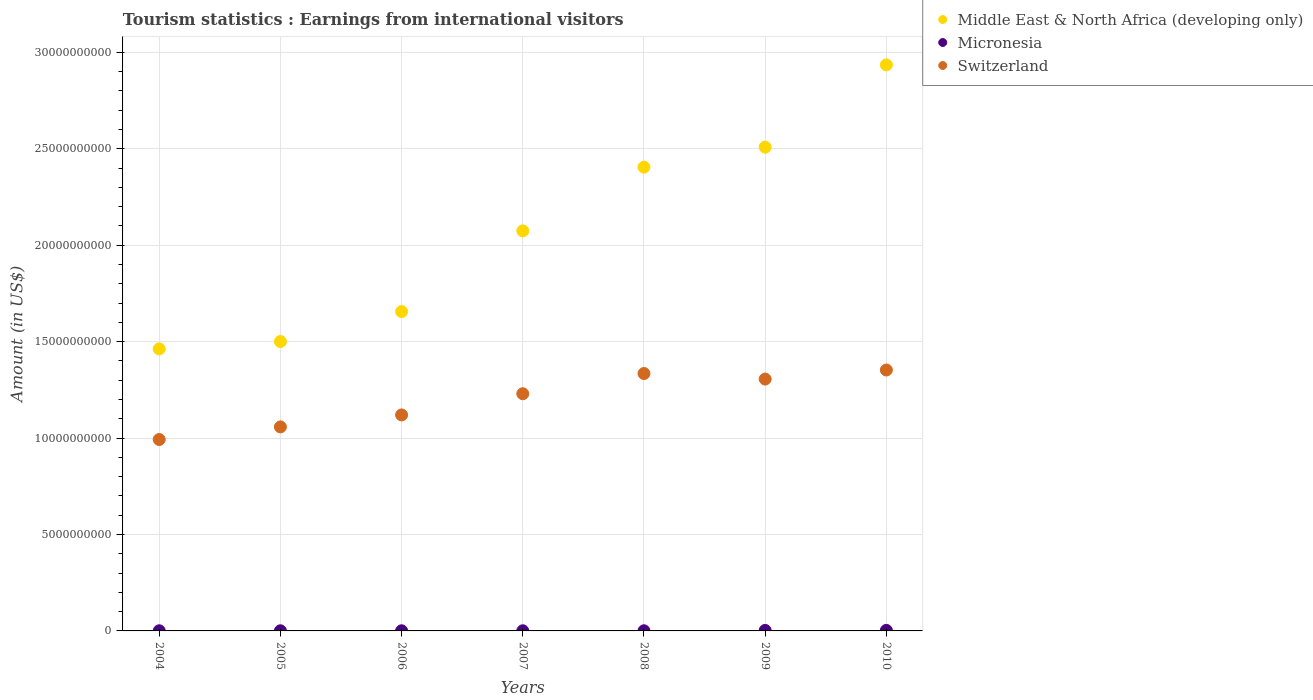How many different coloured dotlines are there?
Offer a terse response. 3. What is the earnings from international visitors in Middle East & North Africa (developing only) in 2009?
Your answer should be compact. 2.51e+1. Across all years, what is the maximum earnings from international visitors in Middle East & North Africa (developing only)?
Provide a short and direct response. 2.93e+1. Across all years, what is the minimum earnings from international visitors in Middle East & North Africa (developing only)?
Your answer should be very brief. 1.46e+1. In which year was the earnings from international visitors in Micronesia maximum?
Your response must be concise. 2010. What is the total earnings from international visitors in Middle East & North Africa (developing only) in the graph?
Offer a terse response. 1.45e+11. What is the difference between the earnings from international visitors in Micronesia in 2006 and that in 2008?
Your answer should be very brief. 0. What is the difference between the earnings from international visitors in Middle East & North Africa (developing only) in 2004 and the earnings from international visitors in Switzerland in 2010?
Your response must be concise. 1.10e+09. What is the average earnings from international visitors in Middle East & North Africa (developing only) per year?
Make the answer very short. 2.08e+1. In the year 2007, what is the difference between the earnings from international visitors in Middle East & North Africa (developing only) and earnings from international visitors in Micronesia?
Offer a terse response. 2.07e+1. What is the ratio of the earnings from international visitors in Micronesia in 2004 to that in 2005?
Provide a short and direct response. 1. Is the difference between the earnings from international visitors in Middle East & North Africa (developing only) in 2006 and 2008 greater than the difference between the earnings from international visitors in Micronesia in 2006 and 2008?
Make the answer very short. No. What is the difference between the highest and the second highest earnings from international visitors in Micronesia?
Give a very brief answer. 2.00e+06. What is the difference between the highest and the lowest earnings from international visitors in Micronesia?
Offer a terse response. 2.10e+07. In how many years, is the earnings from international visitors in Micronesia greater than the average earnings from international visitors in Micronesia taken over all years?
Provide a succinct answer. 2. Is the sum of the earnings from international visitors in Switzerland in 2005 and 2009 greater than the maximum earnings from international visitors in Micronesia across all years?
Offer a terse response. Yes. Is it the case that in every year, the sum of the earnings from international visitors in Micronesia and earnings from international visitors in Middle East & North Africa (developing only)  is greater than the earnings from international visitors in Switzerland?
Your response must be concise. Yes. How many dotlines are there?
Give a very brief answer. 3. Are the values on the major ticks of Y-axis written in scientific E-notation?
Keep it short and to the point. No. How are the legend labels stacked?
Make the answer very short. Vertical. What is the title of the graph?
Give a very brief answer. Tourism statistics : Earnings from international visitors. What is the label or title of the X-axis?
Provide a succinct answer. Years. What is the label or title of the Y-axis?
Keep it short and to the point. Amount (in US$). What is the Amount (in US$) in Middle East & North Africa (developing only) in 2004?
Your answer should be compact. 1.46e+1. What is the Amount (in US$) of Micronesia in 2004?
Give a very brief answer. 7.00e+06. What is the Amount (in US$) in Switzerland in 2004?
Offer a terse response. 9.92e+09. What is the Amount (in US$) in Middle East & North Africa (developing only) in 2005?
Make the answer very short. 1.50e+1. What is the Amount (in US$) of Micronesia in 2005?
Offer a terse response. 7.00e+06. What is the Amount (in US$) in Switzerland in 2005?
Make the answer very short. 1.06e+1. What is the Amount (in US$) in Middle East & North Africa (developing only) in 2006?
Your answer should be compact. 1.66e+1. What is the Amount (in US$) in Micronesia in 2006?
Provide a short and direct response. 7.00e+06. What is the Amount (in US$) in Switzerland in 2006?
Your answer should be very brief. 1.12e+1. What is the Amount (in US$) in Middle East & North Africa (developing only) in 2007?
Ensure brevity in your answer.  2.07e+1. What is the Amount (in US$) in Micronesia in 2007?
Your answer should be very brief. 7.00e+06. What is the Amount (in US$) in Switzerland in 2007?
Ensure brevity in your answer.  1.23e+1. What is the Amount (in US$) in Middle East & North Africa (developing only) in 2008?
Provide a succinct answer. 2.40e+1. What is the Amount (in US$) in Switzerland in 2008?
Give a very brief answer. 1.33e+1. What is the Amount (in US$) of Middle East & North Africa (developing only) in 2009?
Ensure brevity in your answer.  2.51e+1. What is the Amount (in US$) of Micronesia in 2009?
Provide a short and direct response. 2.60e+07. What is the Amount (in US$) in Switzerland in 2009?
Make the answer very short. 1.31e+1. What is the Amount (in US$) of Middle East & North Africa (developing only) in 2010?
Ensure brevity in your answer.  2.93e+1. What is the Amount (in US$) in Micronesia in 2010?
Your answer should be compact. 2.80e+07. What is the Amount (in US$) of Switzerland in 2010?
Your answer should be very brief. 1.35e+1. Across all years, what is the maximum Amount (in US$) in Middle East & North Africa (developing only)?
Your answer should be very brief. 2.93e+1. Across all years, what is the maximum Amount (in US$) in Micronesia?
Give a very brief answer. 2.80e+07. Across all years, what is the maximum Amount (in US$) in Switzerland?
Give a very brief answer. 1.35e+1. Across all years, what is the minimum Amount (in US$) in Middle East & North Africa (developing only)?
Keep it short and to the point. 1.46e+1. Across all years, what is the minimum Amount (in US$) of Micronesia?
Your answer should be compact. 7.00e+06. Across all years, what is the minimum Amount (in US$) in Switzerland?
Your response must be concise. 9.92e+09. What is the total Amount (in US$) in Middle East & North Africa (developing only) in the graph?
Provide a short and direct response. 1.45e+11. What is the total Amount (in US$) of Micronesia in the graph?
Provide a succinct answer. 8.90e+07. What is the total Amount (in US$) in Switzerland in the graph?
Ensure brevity in your answer.  8.39e+1. What is the difference between the Amount (in US$) of Middle East & North Africa (developing only) in 2004 and that in 2005?
Your response must be concise. -3.82e+08. What is the difference between the Amount (in US$) of Switzerland in 2004 and that in 2005?
Offer a very short reply. -6.55e+08. What is the difference between the Amount (in US$) in Middle East & North Africa (developing only) in 2004 and that in 2006?
Offer a very short reply. -1.93e+09. What is the difference between the Amount (in US$) in Micronesia in 2004 and that in 2006?
Keep it short and to the point. 0. What is the difference between the Amount (in US$) in Switzerland in 2004 and that in 2006?
Your answer should be very brief. -1.28e+09. What is the difference between the Amount (in US$) of Middle East & North Africa (developing only) in 2004 and that in 2007?
Your answer should be very brief. -6.12e+09. What is the difference between the Amount (in US$) in Micronesia in 2004 and that in 2007?
Your answer should be compact. 0. What is the difference between the Amount (in US$) of Switzerland in 2004 and that in 2007?
Your answer should be compact. -2.37e+09. What is the difference between the Amount (in US$) in Middle East & North Africa (developing only) in 2004 and that in 2008?
Offer a very short reply. -9.42e+09. What is the difference between the Amount (in US$) in Micronesia in 2004 and that in 2008?
Your answer should be very brief. 0. What is the difference between the Amount (in US$) of Switzerland in 2004 and that in 2008?
Keep it short and to the point. -3.42e+09. What is the difference between the Amount (in US$) in Middle East & North Africa (developing only) in 2004 and that in 2009?
Ensure brevity in your answer.  -1.05e+1. What is the difference between the Amount (in US$) in Micronesia in 2004 and that in 2009?
Keep it short and to the point. -1.90e+07. What is the difference between the Amount (in US$) in Switzerland in 2004 and that in 2009?
Offer a terse response. -3.13e+09. What is the difference between the Amount (in US$) in Middle East & North Africa (developing only) in 2004 and that in 2010?
Make the answer very short. -1.47e+1. What is the difference between the Amount (in US$) of Micronesia in 2004 and that in 2010?
Offer a terse response. -2.10e+07. What is the difference between the Amount (in US$) of Switzerland in 2004 and that in 2010?
Make the answer very short. -3.60e+09. What is the difference between the Amount (in US$) of Middle East & North Africa (developing only) in 2005 and that in 2006?
Ensure brevity in your answer.  -1.55e+09. What is the difference between the Amount (in US$) of Switzerland in 2005 and that in 2006?
Provide a short and direct response. -6.20e+08. What is the difference between the Amount (in US$) of Middle East & North Africa (developing only) in 2005 and that in 2007?
Keep it short and to the point. -5.74e+09. What is the difference between the Amount (in US$) of Micronesia in 2005 and that in 2007?
Give a very brief answer. 0. What is the difference between the Amount (in US$) in Switzerland in 2005 and that in 2007?
Your answer should be compact. -1.72e+09. What is the difference between the Amount (in US$) of Middle East & North Africa (developing only) in 2005 and that in 2008?
Your answer should be very brief. -9.04e+09. What is the difference between the Amount (in US$) of Switzerland in 2005 and that in 2008?
Give a very brief answer. -2.77e+09. What is the difference between the Amount (in US$) of Middle East & North Africa (developing only) in 2005 and that in 2009?
Make the answer very short. -1.01e+1. What is the difference between the Amount (in US$) in Micronesia in 2005 and that in 2009?
Your answer should be very brief. -1.90e+07. What is the difference between the Amount (in US$) of Switzerland in 2005 and that in 2009?
Your answer should be compact. -2.48e+09. What is the difference between the Amount (in US$) in Middle East & North Africa (developing only) in 2005 and that in 2010?
Provide a short and direct response. -1.43e+1. What is the difference between the Amount (in US$) of Micronesia in 2005 and that in 2010?
Make the answer very short. -2.10e+07. What is the difference between the Amount (in US$) of Switzerland in 2005 and that in 2010?
Provide a succinct answer. -2.95e+09. What is the difference between the Amount (in US$) of Middle East & North Africa (developing only) in 2006 and that in 2007?
Ensure brevity in your answer.  -4.18e+09. What is the difference between the Amount (in US$) in Switzerland in 2006 and that in 2007?
Make the answer very short. -1.10e+09. What is the difference between the Amount (in US$) of Middle East & North Africa (developing only) in 2006 and that in 2008?
Make the answer very short. -7.49e+09. What is the difference between the Amount (in US$) of Micronesia in 2006 and that in 2008?
Your response must be concise. 0. What is the difference between the Amount (in US$) of Switzerland in 2006 and that in 2008?
Your answer should be compact. -2.15e+09. What is the difference between the Amount (in US$) of Middle East & North Africa (developing only) in 2006 and that in 2009?
Your answer should be compact. -8.52e+09. What is the difference between the Amount (in US$) of Micronesia in 2006 and that in 2009?
Offer a very short reply. -1.90e+07. What is the difference between the Amount (in US$) in Switzerland in 2006 and that in 2009?
Make the answer very short. -1.86e+09. What is the difference between the Amount (in US$) in Middle East & North Africa (developing only) in 2006 and that in 2010?
Keep it short and to the point. -1.28e+1. What is the difference between the Amount (in US$) in Micronesia in 2006 and that in 2010?
Your response must be concise. -2.10e+07. What is the difference between the Amount (in US$) in Switzerland in 2006 and that in 2010?
Your answer should be compact. -2.33e+09. What is the difference between the Amount (in US$) in Middle East & North Africa (developing only) in 2007 and that in 2008?
Offer a terse response. -3.30e+09. What is the difference between the Amount (in US$) of Micronesia in 2007 and that in 2008?
Keep it short and to the point. 0. What is the difference between the Amount (in US$) of Switzerland in 2007 and that in 2008?
Make the answer very short. -1.05e+09. What is the difference between the Amount (in US$) of Middle East & North Africa (developing only) in 2007 and that in 2009?
Provide a short and direct response. -4.34e+09. What is the difference between the Amount (in US$) in Micronesia in 2007 and that in 2009?
Your answer should be very brief. -1.90e+07. What is the difference between the Amount (in US$) in Switzerland in 2007 and that in 2009?
Your answer should be compact. -7.60e+08. What is the difference between the Amount (in US$) in Middle East & North Africa (developing only) in 2007 and that in 2010?
Give a very brief answer. -8.61e+09. What is the difference between the Amount (in US$) in Micronesia in 2007 and that in 2010?
Provide a succinct answer. -2.10e+07. What is the difference between the Amount (in US$) of Switzerland in 2007 and that in 2010?
Provide a succinct answer. -1.23e+09. What is the difference between the Amount (in US$) in Middle East & North Africa (developing only) in 2008 and that in 2009?
Your answer should be compact. -1.04e+09. What is the difference between the Amount (in US$) of Micronesia in 2008 and that in 2009?
Provide a succinct answer. -1.90e+07. What is the difference between the Amount (in US$) of Switzerland in 2008 and that in 2009?
Your answer should be very brief. 2.88e+08. What is the difference between the Amount (in US$) in Middle East & North Africa (developing only) in 2008 and that in 2010?
Your response must be concise. -5.30e+09. What is the difference between the Amount (in US$) in Micronesia in 2008 and that in 2010?
Make the answer very short. -2.10e+07. What is the difference between the Amount (in US$) of Switzerland in 2008 and that in 2010?
Make the answer very short. -1.82e+08. What is the difference between the Amount (in US$) of Middle East & North Africa (developing only) in 2009 and that in 2010?
Make the answer very short. -4.27e+09. What is the difference between the Amount (in US$) in Switzerland in 2009 and that in 2010?
Your response must be concise. -4.70e+08. What is the difference between the Amount (in US$) of Middle East & North Africa (developing only) in 2004 and the Amount (in US$) of Micronesia in 2005?
Give a very brief answer. 1.46e+1. What is the difference between the Amount (in US$) in Middle East & North Africa (developing only) in 2004 and the Amount (in US$) in Switzerland in 2005?
Your answer should be very brief. 4.04e+09. What is the difference between the Amount (in US$) in Micronesia in 2004 and the Amount (in US$) in Switzerland in 2005?
Ensure brevity in your answer.  -1.06e+1. What is the difference between the Amount (in US$) of Middle East & North Africa (developing only) in 2004 and the Amount (in US$) of Micronesia in 2006?
Keep it short and to the point. 1.46e+1. What is the difference between the Amount (in US$) in Middle East & North Africa (developing only) in 2004 and the Amount (in US$) in Switzerland in 2006?
Ensure brevity in your answer.  3.42e+09. What is the difference between the Amount (in US$) in Micronesia in 2004 and the Amount (in US$) in Switzerland in 2006?
Your response must be concise. -1.12e+1. What is the difference between the Amount (in US$) in Middle East & North Africa (developing only) in 2004 and the Amount (in US$) in Micronesia in 2007?
Keep it short and to the point. 1.46e+1. What is the difference between the Amount (in US$) of Middle East & North Africa (developing only) in 2004 and the Amount (in US$) of Switzerland in 2007?
Make the answer very short. 2.33e+09. What is the difference between the Amount (in US$) of Micronesia in 2004 and the Amount (in US$) of Switzerland in 2007?
Provide a short and direct response. -1.23e+1. What is the difference between the Amount (in US$) in Middle East & North Africa (developing only) in 2004 and the Amount (in US$) in Micronesia in 2008?
Provide a short and direct response. 1.46e+1. What is the difference between the Amount (in US$) of Middle East & North Africa (developing only) in 2004 and the Amount (in US$) of Switzerland in 2008?
Provide a succinct answer. 1.28e+09. What is the difference between the Amount (in US$) of Micronesia in 2004 and the Amount (in US$) of Switzerland in 2008?
Make the answer very short. -1.33e+1. What is the difference between the Amount (in US$) in Middle East & North Africa (developing only) in 2004 and the Amount (in US$) in Micronesia in 2009?
Offer a very short reply. 1.46e+1. What is the difference between the Amount (in US$) in Middle East & North Africa (developing only) in 2004 and the Amount (in US$) in Switzerland in 2009?
Your response must be concise. 1.57e+09. What is the difference between the Amount (in US$) in Micronesia in 2004 and the Amount (in US$) in Switzerland in 2009?
Your answer should be very brief. -1.31e+1. What is the difference between the Amount (in US$) of Middle East & North Africa (developing only) in 2004 and the Amount (in US$) of Micronesia in 2010?
Provide a succinct answer. 1.46e+1. What is the difference between the Amount (in US$) of Middle East & North Africa (developing only) in 2004 and the Amount (in US$) of Switzerland in 2010?
Give a very brief answer. 1.10e+09. What is the difference between the Amount (in US$) in Micronesia in 2004 and the Amount (in US$) in Switzerland in 2010?
Offer a terse response. -1.35e+1. What is the difference between the Amount (in US$) of Middle East & North Africa (developing only) in 2005 and the Amount (in US$) of Micronesia in 2006?
Make the answer very short. 1.50e+1. What is the difference between the Amount (in US$) of Middle East & North Africa (developing only) in 2005 and the Amount (in US$) of Switzerland in 2006?
Provide a succinct answer. 3.81e+09. What is the difference between the Amount (in US$) of Micronesia in 2005 and the Amount (in US$) of Switzerland in 2006?
Offer a very short reply. -1.12e+1. What is the difference between the Amount (in US$) of Middle East & North Africa (developing only) in 2005 and the Amount (in US$) of Micronesia in 2007?
Provide a short and direct response. 1.50e+1. What is the difference between the Amount (in US$) in Middle East & North Africa (developing only) in 2005 and the Amount (in US$) in Switzerland in 2007?
Offer a terse response. 2.71e+09. What is the difference between the Amount (in US$) of Micronesia in 2005 and the Amount (in US$) of Switzerland in 2007?
Provide a succinct answer. -1.23e+1. What is the difference between the Amount (in US$) of Middle East & North Africa (developing only) in 2005 and the Amount (in US$) of Micronesia in 2008?
Offer a terse response. 1.50e+1. What is the difference between the Amount (in US$) of Middle East & North Africa (developing only) in 2005 and the Amount (in US$) of Switzerland in 2008?
Provide a short and direct response. 1.66e+09. What is the difference between the Amount (in US$) of Micronesia in 2005 and the Amount (in US$) of Switzerland in 2008?
Your answer should be compact. -1.33e+1. What is the difference between the Amount (in US$) in Middle East & North Africa (developing only) in 2005 and the Amount (in US$) in Micronesia in 2009?
Your response must be concise. 1.50e+1. What is the difference between the Amount (in US$) in Middle East & North Africa (developing only) in 2005 and the Amount (in US$) in Switzerland in 2009?
Make the answer very short. 1.95e+09. What is the difference between the Amount (in US$) in Micronesia in 2005 and the Amount (in US$) in Switzerland in 2009?
Give a very brief answer. -1.31e+1. What is the difference between the Amount (in US$) in Middle East & North Africa (developing only) in 2005 and the Amount (in US$) in Micronesia in 2010?
Provide a succinct answer. 1.50e+1. What is the difference between the Amount (in US$) of Middle East & North Africa (developing only) in 2005 and the Amount (in US$) of Switzerland in 2010?
Offer a terse response. 1.48e+09. What is the difference between the Amount (in US$) in Micronesia in 2005 and the Amount (in US$) in Switzerland in 2010?
Offer a terse response. -1.35e+1. What is the difference between the Amount (in US$) of Middle East & North Africa (developing only) in 2006 and the Amount (in US$) of Micronesia in 2007?
Give a very brief answer. 1.66e+1. What is the difference between the Amount (in US$) of Middle East & North Africa (developing only) in 2006 and the Amount (in US$) of Switzerland in 2007?
Make the answer very short. 4.26e+09. What is the difference between the Amount (in US$) in Micronesia in 2006 and the Amount (in US$) in Switzerland in 2007?
Your response must be concise. -1.23e+1. What is the difference between the Amount (in US$) in Middle East & North Africa (developing only) in 2006 and the Amount (in US$) in Micronesia in 2008?
Provide a short and direct response. 1.66e+1. What is the difference between the Amount (in US$) in Middle East & North Africa (developing only) in 2006 and the Amount (in US$) in Switzerland in 2008?
Your answer should be very brief. 3.21e+09. What is the difference between the Amount (in US$) of Micronesia in 2006 and the Amount (in US$) of Switzerland in 2008?
Make the answer very short. -1.33e+1. What is the difference between the Amount (in US$) in Middle East & North Africa (developing only) in 2006 and the Amount (in US$) in Micronesia in 2009?
Keep it short and to the point. 1.65e+1. What is the difference between the Amount (in US$) in Middle East & North Africa (developing only) in 2006 and the Amount (in US$) in Switzerland in 2009?
Make the answer very short. 3.50e+09. What is the difference between the Amount (in US$) of Micronesia in 2006 and the Amount (in US$) of Switzerland in 2009?
Give a very brief answer. -1.31e+1. What is the difference between the Amount (in US$) in Middle East & North Africa (developing only) in 2006 and the Amount (in US$) in Micronesia in 2010?
Your answer should be compact. 1.65e+1. What is the difference between the Amount (in US$) of Middle East & North Africa (developing only) in 2006 and the Amount (in US$) of Switzerland in 2010?
Give a very brief answer. 3.03e+09. What is the difference between the Amount (in US$) of Micronesia in 2006 and the Amount (in US$) of Switzerland in 2010?
Your answer should be compact. -1.35e+1. What is the difference between the Amount (in US$) in Middle East & North Africa (developing only) in 2007 and the Amount (in US$) in Micronesia in 2008?
Your answer should be very brief. 2.07e+1. What is the difference between the Amount (in US$) of Middle East & North Africa (developing only) in 2007 and the Amount (in US$) of Switzerland in 2008?
Ensure brevity in your answer.  7.40e+09. What is the difference between the Amount (in US$) of Micronesia in 2007 and the Amount (in US$) of Switzerland in 2008?
Offer a very short reply. -1.33e+1. What is the difference between the Amount (in US$) in Middle East & North Africa (developing only) in 2007 and the Amount (in US$) in Micronesia in 2009?
Make the answer very short. 2.07e+1. What is the difference between the Amount (in US$) of Middle East & North Africa (developing only) in 2007 and the Amount (in US$) of Switzerland in 2009?
Your response must be concise. 7.68e+09. What is the difference between the Amount (in US$) in Micronesia in 2007 and the Amount (in US$) in Switzerland in 2009?
Make the answer very short. -1.31e+1. What is the difference between the Amount (in US$) of Middle East & North Africa (developing only) in 2007 and the Amount (in US$) of Micronesia in 2010?
Make the answer very short. 2.07e+1. What is the difference between the Amount (in US$) in Middle East & North Africa (developing only) in 2007 and the Amount (in US$) in Switzerland in 2010?
Keep it short and to the point. 7.21e+09. What is the difference between the Amount (in US$) in Micronesia in 2007 and the Amount (in US$) in Switzerland in 2010?
Offer a terse response. -1.35e+1. What is the difference between the Amount (in US$) in Middle East & North Africa (developing only) in 2008 and the Amount (in US$) in Micronesia in 2009?
Your answer should be very brief. 2.40e+1. What is the difference between the Amount (in US$) of Middle East & North Africa (developing only) in 2008 and the Amount (in US$) of Switzerland in 2009?
Provide a short and direct response. 1.10e+1. What is the difference between the Amount (in US$) of Micronesia in 2008 and the Amount (in US$) of Switzerland in 2009?
Offer a terse response. -1.31e+1. What is the difference between the Amount (in US$) in Middle East & North Africa (developing only) in 2008 and the Amount (in US$) in Micronesia in 2010?
Keep it short and to the point. 2.40e+1. What is the difference between the Amount (in US$) in Middle East & North Africa (developing only) in 2008 and the Amount (in US$) in Switzerland in 2010?
Provide a succinct answer. 1.05e+1. What is the difference between the Amount (in US$) of Micronesia in 2008 and the Amount (in US$) of Switzerland in 2010?
Give a very brief answer. -1.35e+1. What is the difference between the Amount (in US$) of Middle East & North Africa (developing only) in 2009 and the Amount (in US$) of Micronesia in 2010?
Give a very brief answer. 2.51e+1. What is the difference between the Amount (in US$) in Middle East & North Africa (developing only) in 2009 and the Amount (in US$) in Switzerland in 2010?
Provide a succinct answer. 1.16e+1. What is the difference between the Amount (in US$) in Micronesia in 2009 and the Amount (in US$) in Switzerland in 2010?
Your response must be concise. -1.35e+1. What is the average Amount (in US$) of Middle East & North Africa (developing only) per year?
Your answer should be very brief. 2.08e+1. What is the average Amount (in US$) of Micronesia per year?
Give a very brief answer. 1.27e+07. What is the average Amount (in US$) of Switzerland per year?
Provide a succinct answer. 1.20e+1. In the year 2004, what is the difference between the Amount (in US$) in Middle East & North Africa (developing only) and Amount (in US$) in Micronesia?
Keep it short and to the point. 1.46e+1. In the year 2004, what is the difference between the Amount (in US$) in Middle East & North Africa (developing only) and Amount (in US$) in Switzerland?
Give a very brief answer. 4.70e+09. In the year 2004, what is the difference between the Amount (in US$) in Micronesia and Amount (in US$) in Switzerland?
Your answer should be compact. -9.92e+09. In the year 2005, what is the difference between the Amount (in US$) in Middle East & North Africa (developing only) and Amount (in US$) in Micronesia?
Your answer should be very brief. 1.50e+1. In the year 2005, what is the difference between the Amount (in US$) of Middle East & North Africa (developing only) and Amount (in US$) of Switzerland?
Keep it short and to the point. 4.43e+09. In the year 2005, what is the difference between the Amount (in US$) of Micronesia and Amount (in US$) of Switzerland?
Offer a terse response. -1.06e+1. In the year 2006, what is the difference between the Amount (in US$) of Middle East & North Africa (developing only) and Amount (in US$) of Micronesia?
Keep it short and to the point. 1.66e+1. In the year 2006, what is the difference between the Amount (in US$) of Middle East & North Africa (developing only) and Amount (in US$) of Switzerland?
Your answer should be very brief. 5.36e+09. In the year 2006, what is the difference between the Amount (in US$) of Micronesia and Amount (in US$) of Switzerland?
Provide a succinct answer. -1.12e+1. In the year 2007, what is the difference between the Amount (in US$) in Middle East & North Africa (developing only) and Amount (in US$) in Micronesia?
Offer a very short reply. 2.07e+1. In the year 2007, what is the difference between the Amount (in US$) in Middle East & North Africa (developing only) and Amount (in US$) in Switzerland?
Make the answer very short. 8.44e+09. In the year 2007, what is the difference between the Amount (in US$) in Micronesia and Amount (in US$) in Switzerland?
Keep it short and to the point. -1.23e+1. In the year 2008, what is the difference between the Amount (in US$) of Middle East & North Africa (developing only) and Amount (in US$) of Micronesia?
Offer a very short reply. 2.40e+1. In the year 2008, what is the difference between the Amount (in US$) in Middle East & North Africa (developing only) and Amount (in US$) in Switzerland?
Keep it short and to the point. 1.07e+1. In the year 2008, what is the difference between the Amount (in US$) in Micronesia and Amount (in US$) in Switzerland?
Your answer should be compact. -1.33e+1. In the year 2009, what is the difference between the Amount (in US$) in Middle East & North Africa (developing only) and Amount (in US$) in Micronesia?
Provide a short and direct response. 2.51e+1. In the year 2009, what is the difference between the Amount (in US$) in Middle East & North Africa (developing only) and Amount (in US$) in Switzerland?
Make the answer very short. 1.20e+1. In the year 2009, what is the difference between the Amount (in US$) in Micronesia and Amount (in US$) in Switzerland?
Ensure brevity in your answer.  -1.30e+1. In the year 2010, what is the difference between the Amount (in US$) in Middle East & North Africa (developing only) and Amount (in US$) in Micronesia?
Your answer should be very brief. 2.93e+1. In the year 2010, what is the difference between the Amount (in US$) in Middle East & North Africa (developing only) and Amount (in US$) in Switzerland?
Offer a very short reply. 1.58e+1. In the year 2010, what is the difference between the Amount (in US$) in Micronesia and Amount (in US$) in Switzerland?
Give a very brief answer. -1.35e+1. What is the ratio of the Amount (in US$) of Middle East & North Africa (developing only) in 2004 to that in 2005?
Your response must be concise. 0.97. What is the ratio of the Amount (in US$) in Switzerland in 2004 to that in 2005?
Your answer should be very brief. 0.94. What is the ratio of the Amount (in US$) in Middle East & North Africa (developing only) in 2004 to that in 2006?
Offer a very short reply. 0.88. What is the ratio of the Amount (in US$) in Micronesia in 2004 to that in 2006?
Your answer should be compact. 1. What is the ratio of the Amount (in US$) in Switzerland in 2004 to that in 2006?
Your answer should be very brief. 0.89. What is the ratio of the Amount (in US$) of Middle East & North Africa (developing only) in 2004 to that in 2007?
Your response must be concise. 0.7. What is the ratio of the Amount (in US$) in Switzerland in 2004 to that in 2007?
Your answer should be very brief. 0.81. What is the ratio of the Amount (in US$) in Middle East & North Africa (developing only) in 2004 to that in 2008?
Give a very brief answer. 0.61. What is the ratio of the Amount (in US$) in Micronesia in 2004 to that in 2008?
Your answer should be very brief. 1. What is the ratio of the Amount (in US$) in Switzerland in 2004 to that in 2008?
Provide a succinct answer. 0.74. What is the ratio of the Amount (in US$) of Middle East & North Africa (developing only) in 2004 to that in 2009?
Offer a very short reply. 0.58. What is the ratio of the Amount (in US$) of Micronesia in 2004 to that in 2009?
Provide a succinct answer. 0.27. What is the ratio of the Amount (in US$) of Switzerland in 2004 to that in 2009?
Your answer should be compact. 0.76. What is the ratio of the Amount (in US$) of Middle East & North Africa (developing only) in 2004 to that in 2010?
Your answer should be compact. 0.5. What is the ratio of the Amount (in US$) of Micronesia in 2004 to that in 2010?
Offer a terse response. 0.25. What is the ratio of the Amount (in US$) in Switzerland in 2004 to that in 2010?
Your response must be concise. 0.73. What is the ratio of the Amount (in US$) of Middle East & North Africa (developing only) in 2005 to that in 2006?
Your answer should be compact. 0.91. What is the ratio of the Amount (in US$) in Micronesia in 2005 to that in 2006?
Keep it short and to the point. 1. What is the ratio of the Amount (in US$) in Switzerland in 2005 to that in 2006?
Offer a very short reply. 0.94. What is the ratio of the Amount (in US$) in Middle East & North Africa (developing only) in 2005 to that in 2007?
Provide a succinct answer. 0.72. What is the ratio of the Amount (in US$) in Micronesia in 2005 to that in 2007?
Your answer should be very brief. 1. What is the ratio of the Amount (in US$) of Switzerland in 2005 to that in 2007?
Make the answer very short. 0.86. What is the ratio of the Amount (in US$) in Middle East & North Africa (developing only) in 2005 to that in 2008?
Offer a very short reply. 0.62. What is the ratio of the Amount (in US$) of Switzerland in 2005 to that in 2008?
Make the answer very short. 0.79. What is the ratio of the Amount (in US$) of Middle East & North Africa (developing only) in 2005 to that in 2009?
Give a very brief answer. 0.6. What is the ratio of the Amount (in US$) in Micronesia in 2005 to that in 2009?
Your response must be concise. 0.27. What is the ratio of the Amount (in US$) in Switzerland in 2005 to that in 2009?
Provide a succinct answer. 0.81. What is the ratio of the Amount (in US$) of Middle East & North Africa (developing only) in 2005 to that in 2010?
Ensure brevity in your answer.  0.51. What is the ratio of the Amount (in US$) in Switzerland in 2005 to that in 2010?
Your answer should be compact. 0.78. What is the ratio of the Amount (in US$) in Middle East & North Africa (developing only) in 2006 to that in 2007?
Provide a short and direct response. 0.8. What is the ratio of the Amount (in US$) in Micronesia in 2006 to that in 2007?
Give a very brief answer. 1. What is the ratio of the Amount (in US$) of Switzerland in 2006 to that in 2007?
Keep it short and to the point. 0.91. What is the ratio of the Amount (in US$) of Middle East & North Africa (developing only) in 2006 to that in 2008?
Offer a terse response. 0.69. What is the ratio of the Amount (in US$) of Switzerland in 2006 to that in 2008?
Provide a short and direct response. 0.84. What is the ratio of the Amount (in US$) of Middle East & North Africa (developing only) in 2006 to that in 2009?
Make the answer very short. 0.66. What is the ratio of the Amount (in US$) of Micronesia in 2006 to that in 2009?
Ensure brevity in your answer.  0.27. What is the ratio of the Amount (in US$) of Switzerland in 2006 to that in 2009?
Your answer should be compact. 0.86. What is the ratio of the Amount (in US$) of Middle East & North Africa (developing only) in 2006 to that in 2010?
Keep it short and to the point. 0.56. What is the ratio of the Amount (in US$) of Micronesia in 2006 to that in 2010?
Provide a short and direct response. 0.25. What is the ratio of the Amount (in US$) of Switzerland in 2006 to that in 2010?
Keep it short and to the point. 0.83. What is the ratio of the Amount (in US$) in Middle East & North Africa (developing only) in 2007 to that in 2008?
Offer a very short reply. 0.86. What is the ratio of the Amount (in US$) of Micronesia in 2007 to that in 2008?
Your answer should be compact. 1. What is the ratio of the Amount (in US$) of Switzerland in 2007 to that in 2008?
Offer a terse response. 0.92. What is the ratio of the Amount (in US$) of Middle East & North Africa (developing only) in 2007 to that in 2009?
Keep it short and to the point. 0.83. What is the ratio of the Amount (in US$) of Micronesia in 2007 to that in 2009?
Give a very brief answer. 0.27. What is the ratio of the Amount (in US$) of Switzerland in 2007 to that in 2009?
Ensure brevity in your answer.  0.94. What is the ratio of the Amount (in US$) in Middle East & North Africa (developing only) in 2007 to that in 2010?
Give a very brief answer. 0.71. What is the ratio of the Amount (in US$) in Micronesia in 2007 to that in 2010?
Provide a short and direct response. 0.25. What is the ratio of the Amount (in US$) in Middle East & North Africa (developing only) in 2008 to that in 2009?
Give a very brief answer. 0.96. What is the ratio of the Amount (in US$) in Micronesia in 2008 to that in 2009?
Your answer should be very brief. 0.27. What is the ratio of the Amount (in US$) of Switzerland in 2008 to that in 2009?
Keep it short and to the point. 1.02. What is the ratio of the Amount (in US$) of Middle East & North Africa (developing only) in 2008 to that in 2010?
Your response must be concise. 0.82. What is the ratio of the Amount (in US$) in Micronesia in 2008 to that in 2010?
Give a very brief answer. 0.25. What is the ratio of the Amount (in US$) in Switzerland in 2008 to that in 2010?
Provide a short and direct response. 0.99. What is the ratio of the Amount (in US$) of Middle East & North Africa (developing only) in 2009 to that in 2010?
Keep it short and to the point. 0.85. What is the ratio of the Amount (in US$) in Switzerland in 2009 to that in 2010?
Make the answer very short. 0.97. What is the difference between the highest and the second highest Amount (in US$) of Middle East & North Africa (developing only)?
Offer a terse response. 4.27e+09. What is the difference between the highest and the second highest Amount (in US$) of Micronesia?
Offer a very short reply. 2.00e+06. What is the difference between the highest and the second highest Amount (in US$) of Switzerland?
Make the answer very short. 1.82e+08. What is the difference between the highest and the lowest Amount (in US$) in Middle East & North Africa (developing only)?
Ensure brevity in your answer.  1.47e+1. What is the difference between the highest and the lowest Amount (in US$) of Micronesia?
Make the answer very short. 2.10e+07. What is the difference between the highest and the lowest Amount (in US$) of Switzerland?
Give a very brief answer. 3.60e+09. 